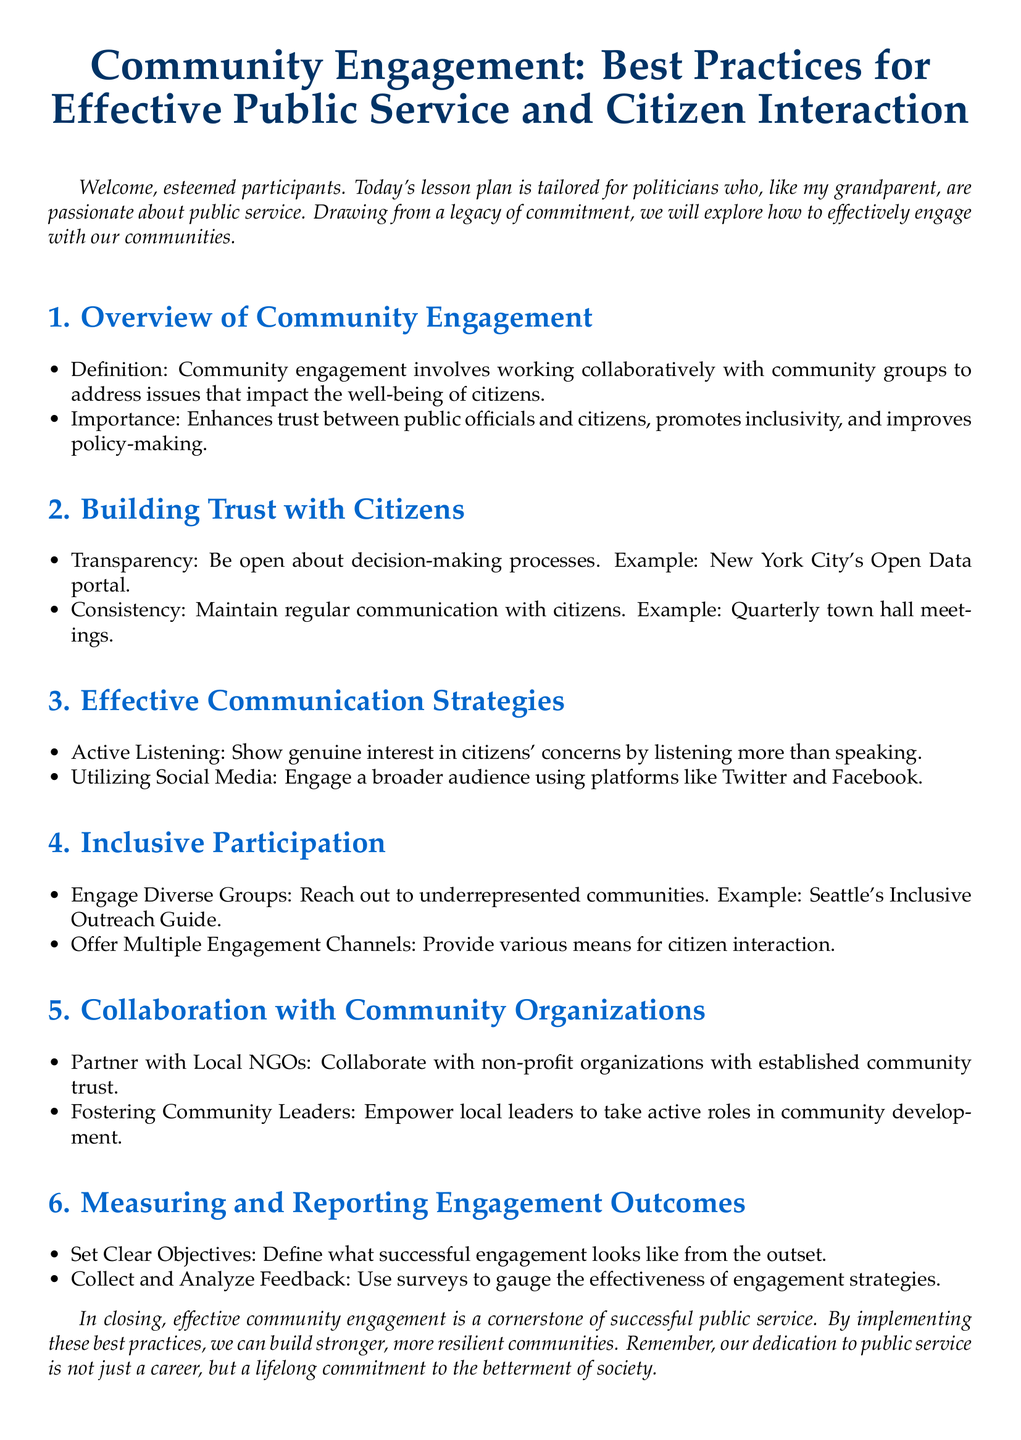What is the title of the lesson plan? The title is prominently displayed at the beginning of the document, which indicates the overall theme of the lesson plan.
Answer: Community Engagement: Best Practices for Effective Public Service and Citizen Interaction What is the main purpose of community engagement? The document outlines the significance of community engagement in improving relationships and policy-making between public officials and citizens.
Answer: Enhance trust What are two examples of effective communication strategies? The document lists specific strategies that politicians can use to connect with citizens, highlighting important communication techniques.
Answer: Active Listening, Utilizing Social Media What is one method to build trust with citizens? The lesson plan mentions a specific practice that can increase trust in public officials among community members.
Answer: Transparency What is the objective of measuring engagement outcomes? The document specifies that having clear objectives is crucial to assessing the effectiveness of engagement activities.
Answer: Define successful engagement How can politicians engage diverse groups? The document provides a strategy for politicians to ensure that all community voices are included in the engagement process.
Answer: Reach out to underrepresented communities What is the significance of fostering community leaders? The lesson plan highlights the benefits of empowering local figures within the community as a means of enhancing development.
Answer: Empower local leaders Which city's initiative is mentioned as an example of transparency? The document uses a specific city as an exemplar of transparency in decision-making processes.
Answer: New York City What type of organizations should politicians partner with? The lesson plan suggests specific types of organizations that are important for collaboration in community engagement efforts.
Answer: Local NGOs 